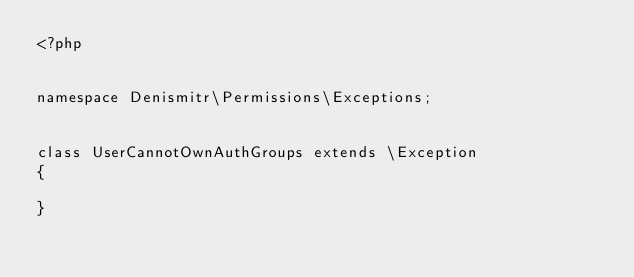Convert code to text. <code><loc_0><loc_0><loc_500><loc_500><_PHP_><?php


namespace Denismitr\Permissions\Exceptions;


class UserCannotOwnAuthGroups extends \Exception
{

}</code> 